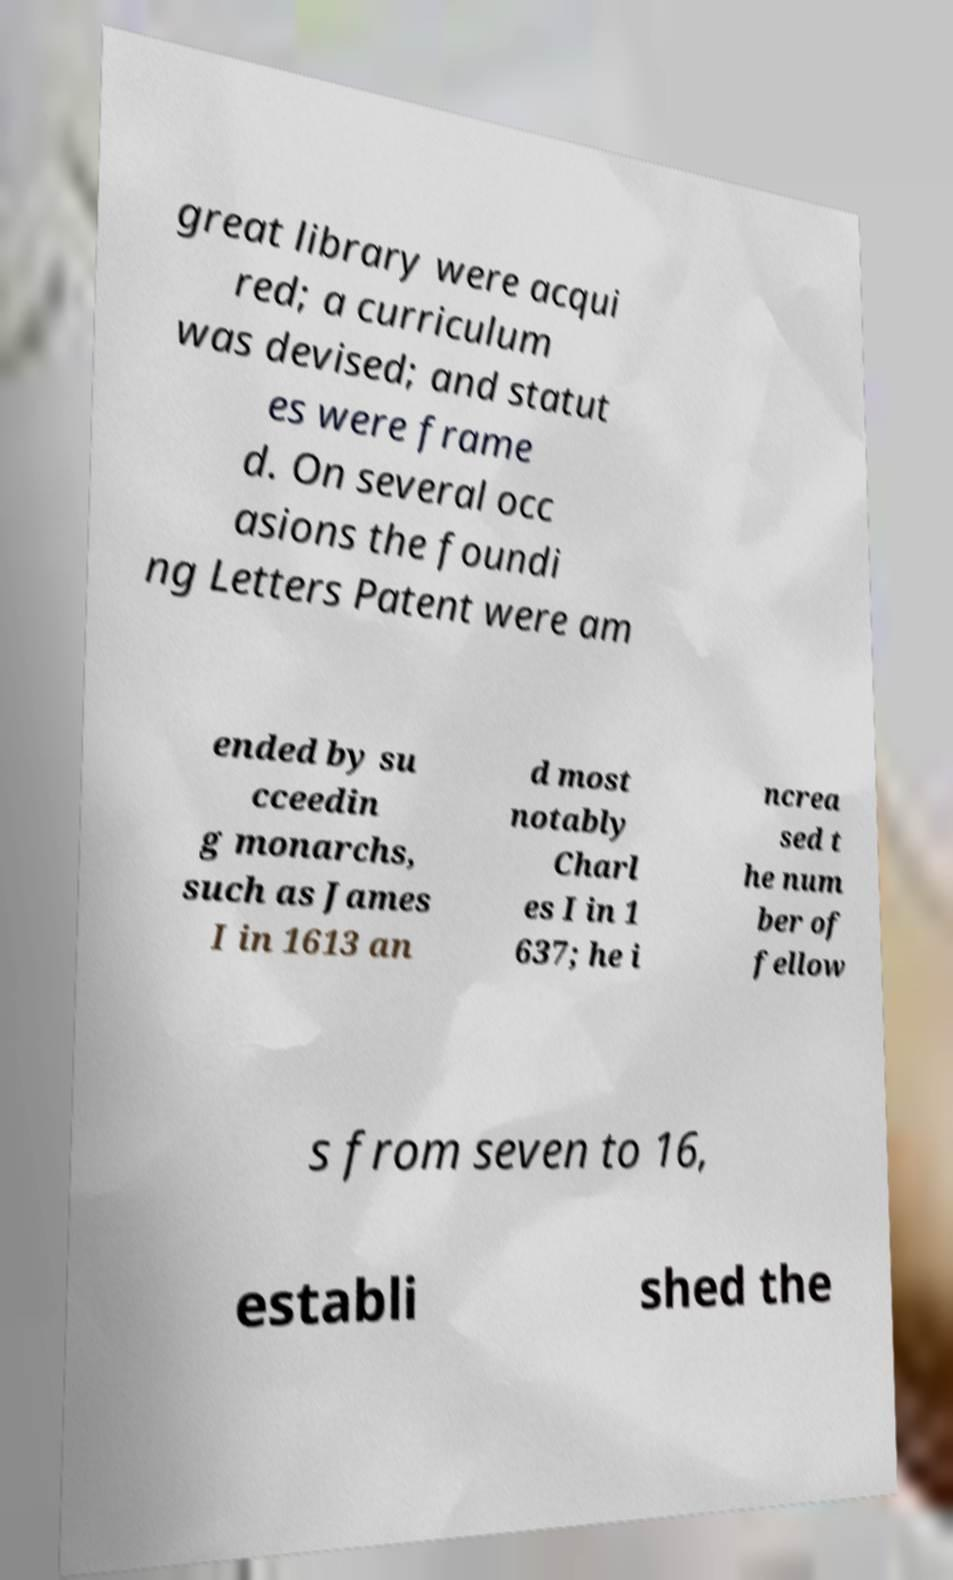What messages or text are displayed in this image? I need them in a readable, typed format. great library were acqui red; a curriculum was devised; and statut es were frame d. On several occ asions the foundi ng Letters Patent were am ended by su cceedin g monarchs, such as James I in 1613 an d most notably Charl es I in 1 637; he i ncrea sed t he num ber of fellow s from seven to 16, establi shed the 